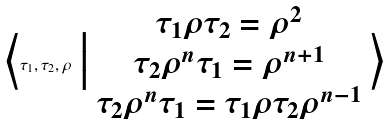Convert formula to latex. <formula><loc_0><loc_0><loc_500><loc_500>\Big \langle \tau _ { 1 } , \tau _ { 2 } , \rho \ \Big | \ \begin{matrix} \tau _ { 1 } \rho \tau _ { 2 } = \rho ^ { 2 } \\ \tau _ { 2 } \rho ^ { n } \tau _ { 1 } = \rho ^ { n + 1 } \\ \tau _ { 2 } \rho ^ { n } \tau _ { 1 } = \tau _ { 1 } \rho \tau _ { 2 } \rho ^ { n - 1 } \end{matrix} \ \Big \rangle</formula> 